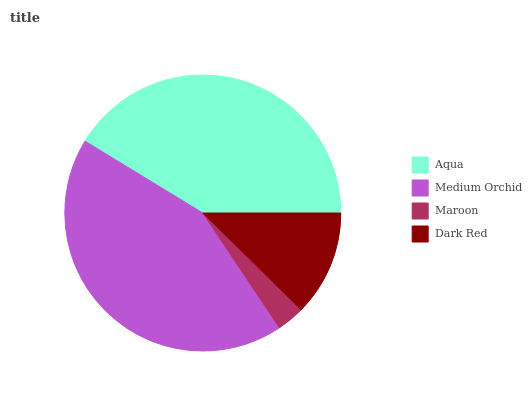Is Maroon the minimum?
Answer yes or no. Yes. Is Medium Orchid the maximum?
Answer yes or no. Yes. Is Medium Orchid the minimum?
Answer yes or no. No. Is Maroon the maximum?
Answer yes or no. No. Is Medium Orchid greater than Maroon?
Answer yes or no. Yes. Is Maroon less than Medium Orchid?
Answer yes or no. Yes. Is Maroon greater than Medium Orchid?
Answer yes or no. No. Is Medium Orchid less than Maroon?
Answer yes or no. No. Is Aqua the high median?
Answer yes or no. Yes. Is Dark Red the low median?
Answer yes or no. Yes. Is Dark Red the high median?
Answer yes or no. No. Is Medium Orchid the low median?
Answer yes or no. No. 